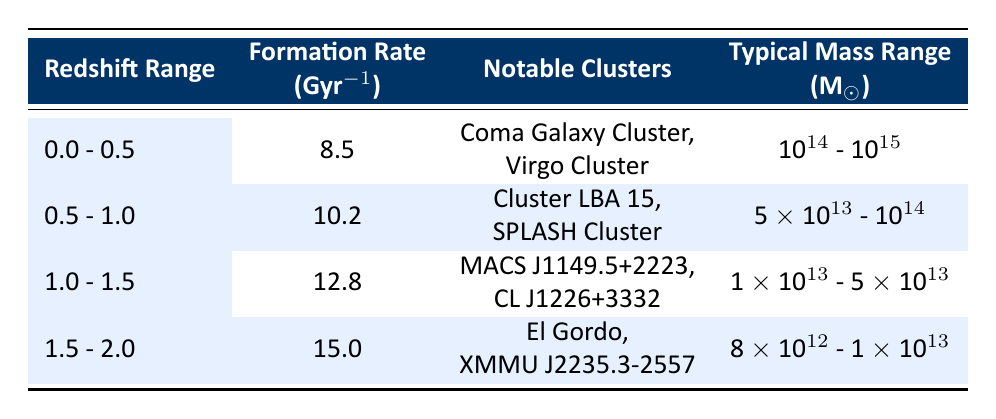What is the formation rate for the redshift range 0.5 - 1.0? From the table, the formation rate for the redshift range 0.5 - 1.0 is listed directly in the relevant column as 10.2 Gyr^-1.
Answer: 10.2 Gyr^-1 Which notable clusters are associated with the redshift range 1.0 - 1.5? By checking the notable clusters column corresponding to the row for the redshift range 1.0 - 1.5, the notable clusters are MACS J1149.5+2223 and CL J1226+3332.
Answer: MACS J1149.5+2223, CL J1226+3332 Is the formation rate for the redshift range 1.5 - 2.0 higher than that for the range 0.0 - 0.5? The formation rates are 15.0 Gyr^-1 for 1.5 - 2.0 and 8.5 Gyr^-1 for 0.0 - 0.5. Since 15.0 is greater than 8.5, the answer is yes.
Answer: Yes What is the typical mass range for the formations in the redshift range 0.0 - 0.5? The typical mass range for that redshift range can be found in the corresponding column, which states it is 10^14 - 10^15.
Answer: 10^14 - 10^15 What is the average formation rate across all redshift ranges? To find the average, sum the formation rates: 8.5 + 10.2 + 12.8 + 15.0 = 46.5. Divide by the number of ranges (4) to get 46.5 / 4 = 11.625.
Answer: 11.625 Gyr^-1 How many notable clusters are associated with the redshift range 0.5 - 1.0? The notable clusters for that range are listed as two: Cluster LBA 15 and SPLASH Cluster.
Answer: 2 Does the typical mass range decrease as redshift increases? By examining the mass ranges, we see that it goes from 10^14 - 10^15 for 0.0 - 0.5, to 5 x 10^13 - 10^14 for 0.5 - 1.0, and so on. The trend shows a decrease in typical mass range as redshift increases.
Answer: Yes What is the difference in formation rates between the redshift ranges 1.0 - 1.5 and 1.5 - 2.0? The formation rate for 1.0 - 1.5 is 12.8 Gyr^-1 and for 1.5 - 2.0 is 15.0 Gyr^-1. The difference is 15.0 - 12.8 = 2.2.
Answer: 2.2 Gyr^-1 